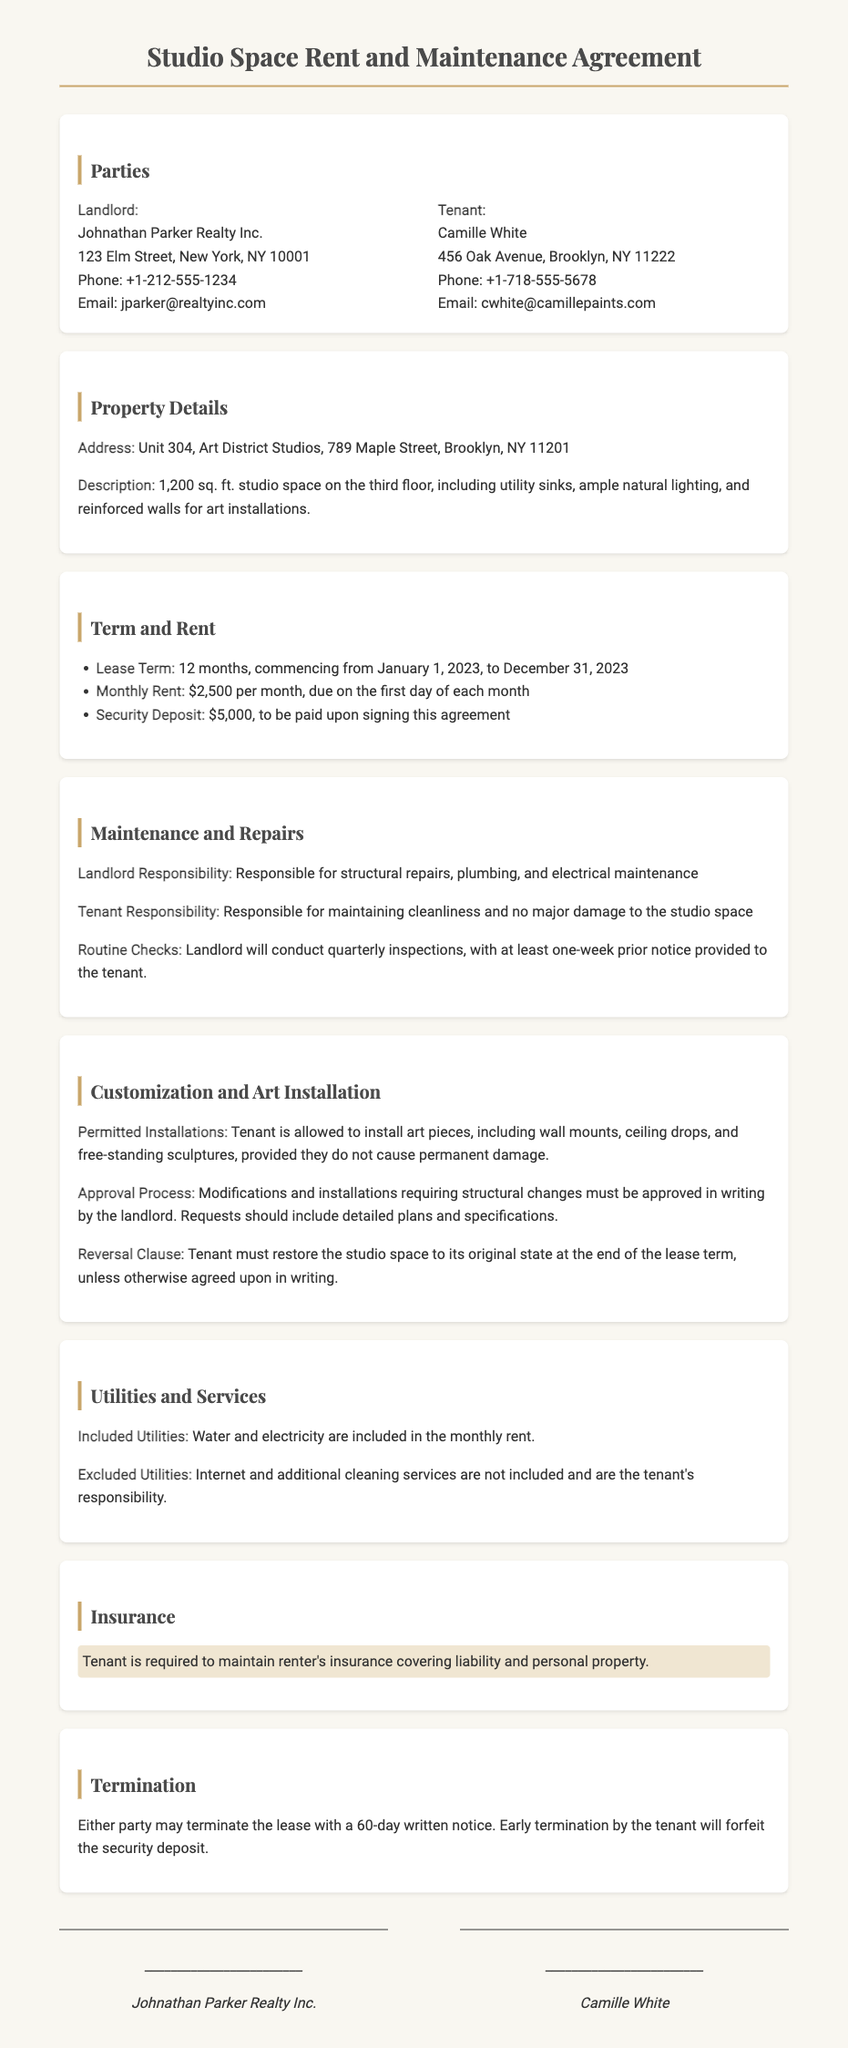What is the address of the studio space? The address provided in the document is the property details section.
Answer: Unit 304, Art District Studios, 789 Maple Street, Brooklyn, NY 11201 Who is the landlord? The landlord's information is included in the parties section of the document.
Answer: Johnathan Parker Realty Inc What is the monthly rent? The rent information is specified in the term and rent section.
Answer: $2,500 per month What is the security deposit amount? The security deposit figure can be found in the term and rent section.
Answer: $5,000 How long is the lease term? The lease term is detailed in the term and rent section.
Answer: 12 months What must the tenant maintain according to the maintenance section? The maintenance responsibilities are outlined in the maintenance and repairs section.
Answer: Cleanliness and no major damage What is required for modifications to the studio space? The customization and art installation section specifies the approval process.
Answer: Written approval from the landlord Are utilities included in the rent? The utilities information is discussed in the utilities and services section.
Answer: Water and electricity What is needed for tenant's insurance? Insurance requirements are highlighted in the insurance section.
Answer: Renter's insurance covering liability and personal property What happens upon early termination of the lease? The termination section discusses consequences related to lease termination.
Answer: Forfeit the security deposit 